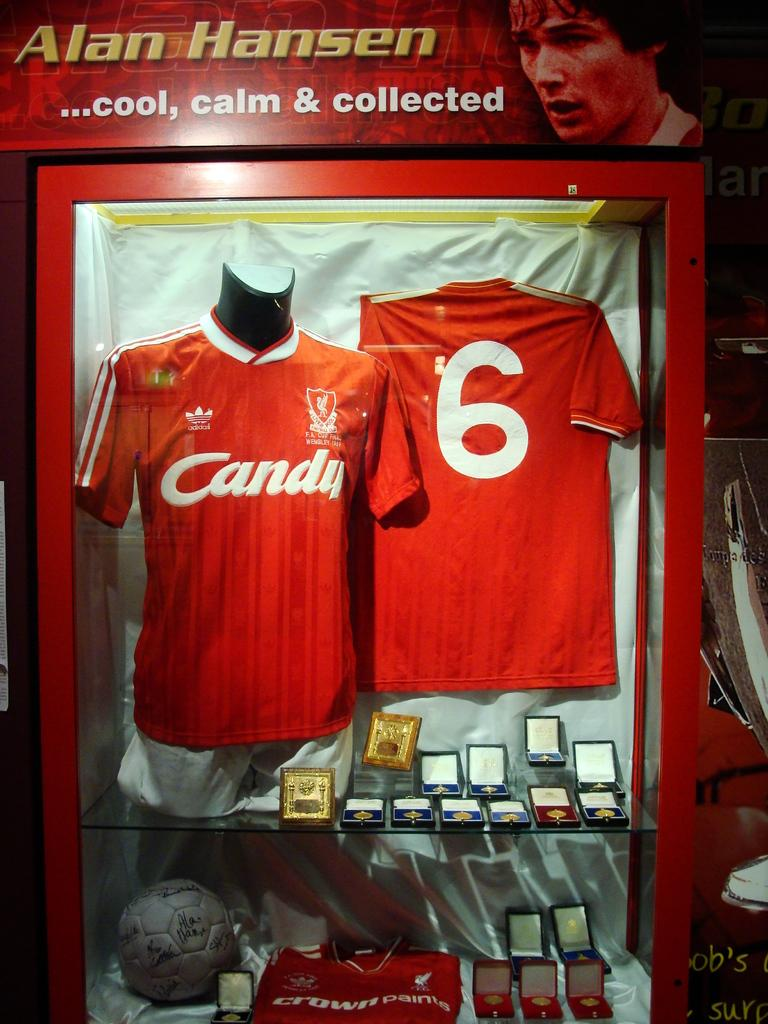<image>
Present a compact description of the photo's key features. 2 red jerseys that read candy number 6 